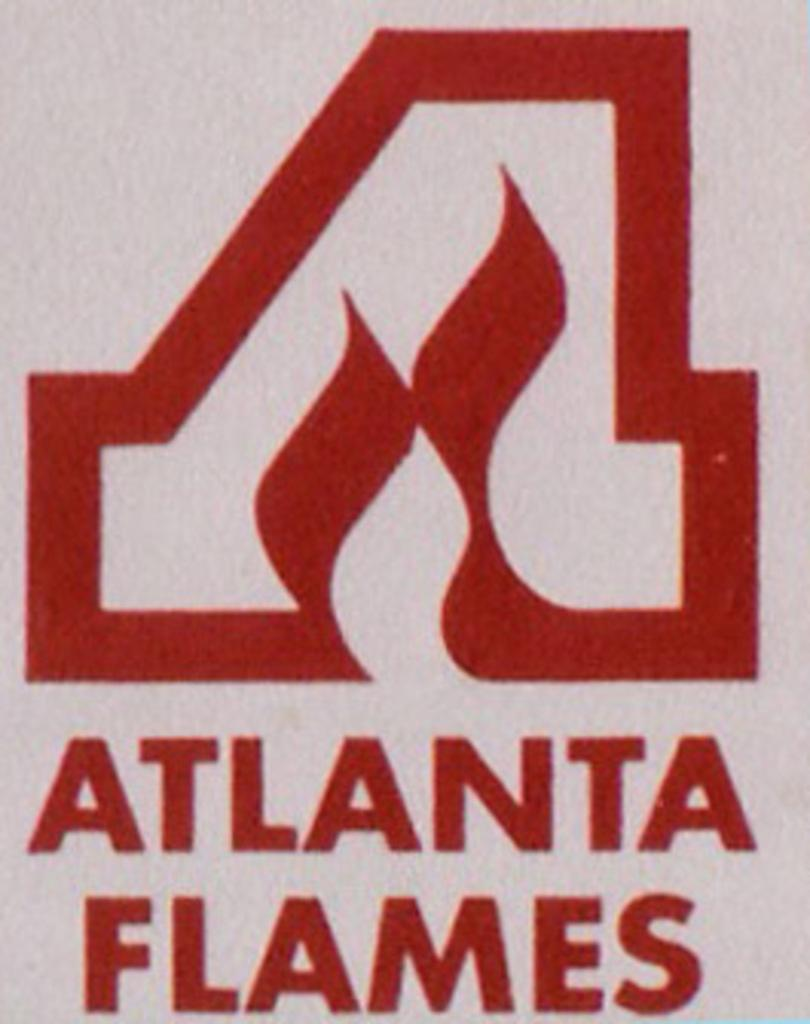<image>
Give a short and clear explanation of the subsequent image. A logo for Atlanta Flames is red on a white background. 